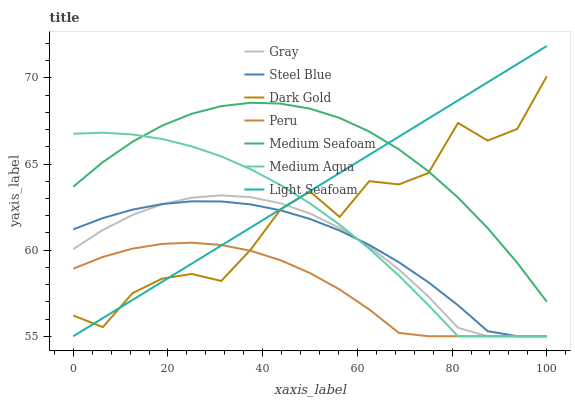Does Peru have the minimum area under the curve?
Answer yes or no. Yes. Does Medium Seafoam have the maximum area under the curve?
Answer yes or no. Yes. Does Dark Gold have the minimum area under the curve?
Answer yes or no. No. Does Dark Gold have the maximum area under the curve?
Answer yes or no. No. Is Light Seafoam the smoothest?
Answer yes or no. Yes. Is Dark Gold the roughest?
Answer yes or no. Yes. Is Steel Blue the smoothest?
Answer yes or no. No. Is Steel Blue the roughest?
Answer yes or no. No. Does Dark Gold have the lowest value?
Answer yes or no. No. Does Light Seafoam have the highest value?
Answer yes or no. Yes. Does Dark Gold have the highest value?
Answer yes or no. No. Is Steel Blue less than Medium Seafoam?
Answer yes or no. Yes. Is Medium Seafoam greater than Peru?
Answer yes or no. Yes. Does Steel Blue intersect Medium Seafoam?
Answer yes or no. No. 